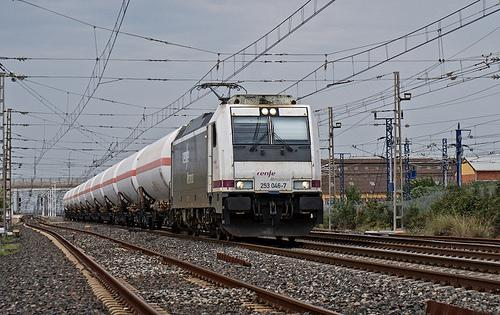Question: where was the photo taken?
Choices:
A. At the beach.
B. At a crime scene.
C. A railway.
D. At the accident.
Answer with the letter. Answer: C Question: what is in the photo?
Choices:
A. The photographer.
B. A train.
C. Art.
D. A dog running.
Answer with the letter. Answer: B Question: what does the train have on?
Choices:
A. Wheels.
B. Passengers.
C. Headlights.
D. Engine.
Answer with the letter. Answer: C Question: what is on the railway?
Choices:
A. Tracks.
B. Train.
C. Gravel.
D. Crossing arms.
Answer with the letter. Answer: C 